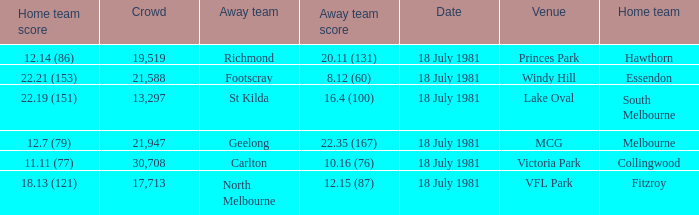What was the away team that played against Fitzroy? North Melbourne. 